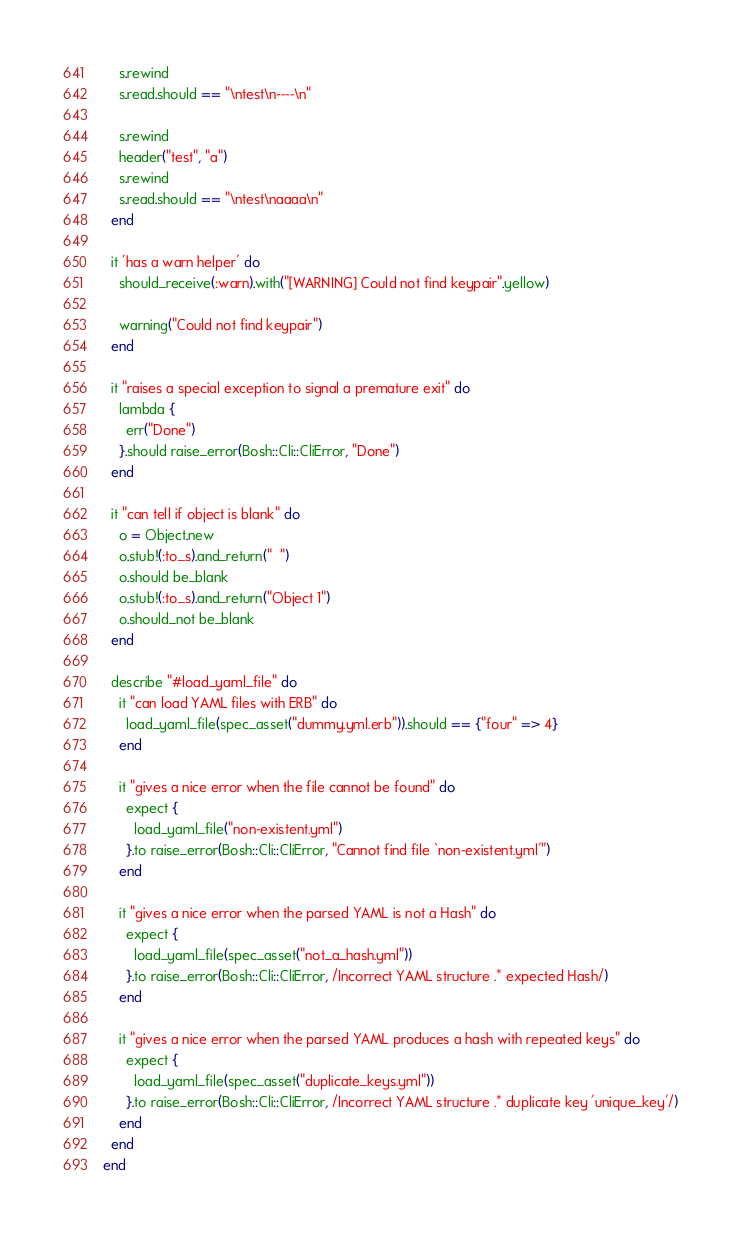<code> <loc_0><loc_0><loc_500><loc_500><_Ruby_>    s.rewind
    s.read.should == "\ntest\n----\n"

    s.rewind
    header("test", "a")
    s.rewind
    s.read.should == "\ntest\naaaa\n"
  end

  it 'has a warn helper' do
    should_receive(:warn).with("[WARNING] Could not find keypair".yellow)

    warning("Could not find keypair")
  end

  it "raises a special exception to signal a premature exit" do
    lambda {
      err("Done")
    }.should raise_error(Bosh::Cli::CliError, "Done")
  end

  it "can tell if object is blank" do
    o = Object.new
    o.stub!(:to_s).and_return("  ")
    o.should be_blank
    o.stub!(:to_s).and_return("Object 1")
    o.should_not be_blank
  end

  describe "#load_yaml_file" do
    it "can load YAML files with ERB" do
      load_yaml_file(spec_asset("dummy.yml.erb")).should == {"four" => 4}
    end

    it "gives a nice error when the file cannot be found" do
      expect {
        load_yaml_file("non-existent.yml")
      }.to raise_error(Bosh::Cli::CliError, "Cannot find file `non-existent.yml'")
    end

    it "gives a nice error when the parsed YAML is not a Hash" do
      expect {
        load_yaml_file(spec_asset("not_a_hash.yml"))
      }.to raise_error(Bosh::Cli::CliError, /Incorrect YAML structure .* expected Hash/)
    end

    it "gives a nice error when the parsed YAML produces a hash with repeated keys" do
      expect {
        load_yaml_file(spec_asset("duplicate_keys.yml"))
      }.to raise_error(Bosh::Cli::CliError, /Incorrect YAML structure .* duplicate key 'unique_key'/)
    end
  end
end
</code> 